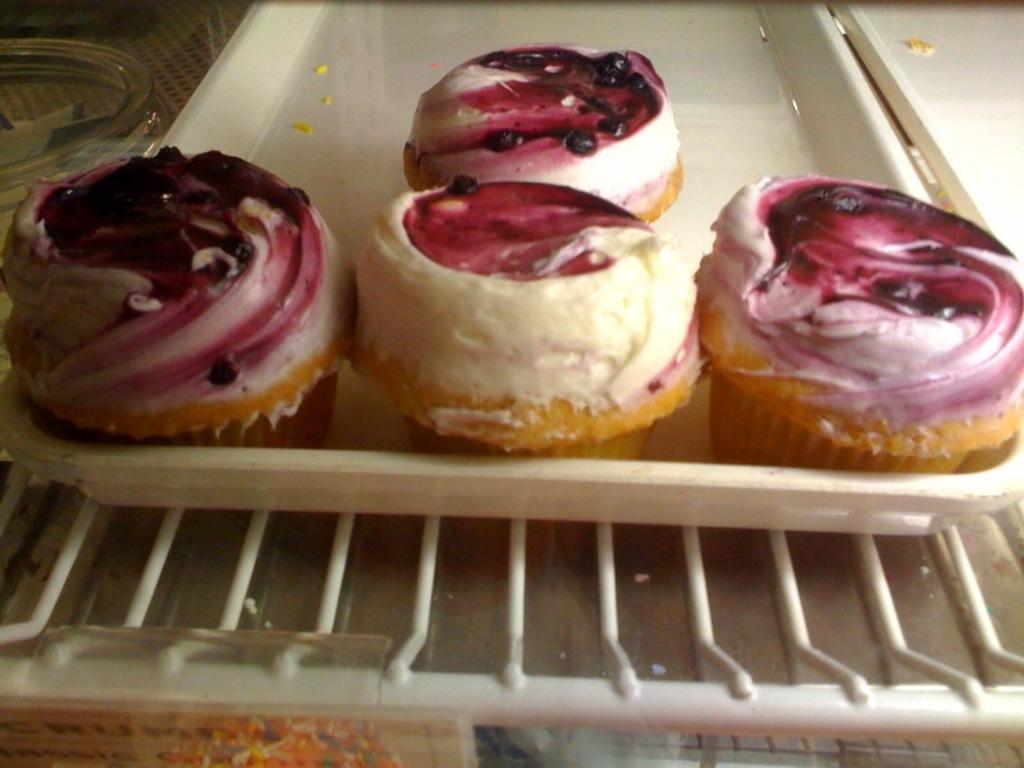In one or two sentences, can you explain what this image depicts? This is an inside view of a refrigerator. In the center of the image we can see the cupcakes are present in a tray. At the bottom of the image we can see the grilles and some other food items. In the top left corner we can see a glass jar. 